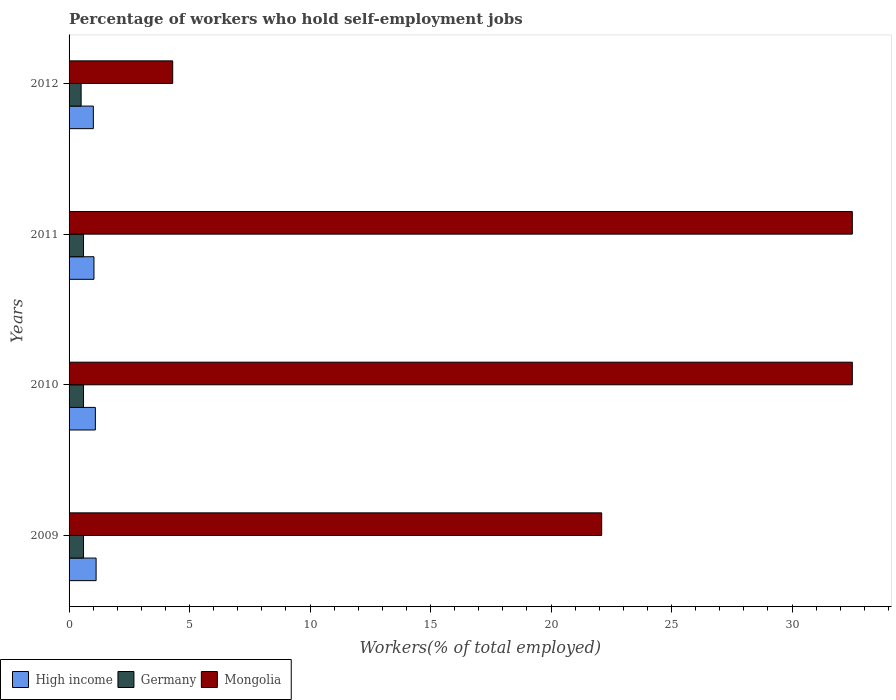How many different coloured bars are there?
Give a very brief answer. 3. How many groups of bars are there?
Make the answer very short. 4. Are the number of bars on each tick of the Y-axis equal?
Provide a succinct answer. Yes. How many bars are there on the 2nd tick from the top?
Offer a very short reply. 3. How many bars are there on the 1st tick from the bottom?
Offer a very short reply. 3. In how many cases, is the number of bars for a given year not equal to the number of legend labels?
Provide a short and direct response. 0. What is the percentage of self-employed workers in Germany in 2010?
Offer a very short reply. 0.6. Across all years, what is the maximum percentage of self-employed workers in Germany?
Offer a very short reply. 0.6. What is the total percentage of self-employed workers in High income in the graph?
Your answer should be very brief. 4.25. What is the difference between the percentage of self-employed workers in Germany in 2010 and the percentage of self-employed workers in High income in 2009?
Offer a terse response. -0.52. What is the average percentage of self-employed workers in High income per year?
Provide a short and direct response. 1.06. In the year 2009, what is the difference between the percentage of self-employed workers in High income and percentage of self-employed workers in Germany?
Keep it short and to the point. 0.52. In how many years, is the percentage of self-employed workers in Mongolia greater than 31 %?
Give a very brief answer. 2. What is the ratio of the percentage of self-employed workers in High income in 2011 to that in 2012?
Make the answer very short. 1.03. Is the difference between the percentage of self-employed workers in High income in 2011 and 2012 greater than the difference between the percentage of self-employed workers in Germany in 2011 and 2012?
Offer a terse response. No. What is the difference between the highest and the lowest percentage of self-employed workers in Mongolia?
Give a very brief answer. 28.2. In how many years, is the percentage of self-employed workers in Germany greater than the average percentage of self-employed workers in Germany taken over all years?
Provide a succinct answer. 3. What does the 1st bar from the bottom in 2011 represents?
Ensure brevity in your answer.  High income. Is it the case that in every year, the sum of the percentage of self-employed workers in High income and percentage of self-employed workers in Mongolia is greater than the percentage of self-employed workers in Germany?
Provide a succinct answer. Yes. How many years are there in the graph?
Keep it short and to the point. 4. Does the graph contain grids?
Your response must be concise. No. How many legend labels are there?
Your answer should be very brief. 3. How are the legend labels stacked?
Provide a short and direct response. Horizontal. What is the title of the graph?
Offer a terse response. Percentage of workers who hold self-employment jobs. What is the label or title of the X-axis?
Give a very brief answer. Workers(% of total employed). What is the label or title of the Y-axis?
Provide a succinct answer. Years. What is the Workers(% of total employed) of High income in 2009?
Your response must be concise. 1.12. What is the Workers(% of total employed) of Germany in 2009?
Make the answer very short. 0.6. What is the Workers(% of total employed) of Mongolia in 2009?
Provide a succinct answer. 22.1. What is the Workers(% of total employed) in High income in 2010?
Offer a very short reply. 1.09. What is the Workers(% of total employed) in Germany in 2010?
Ensure brevity in your answer.  0.6. What is the Workers(% of total employed) in Mongolia in 2010?
Provide a succinct answer. 32.5. What is the Workers(% of total employed) in High income in 2011?
Offer a terse response. 1.03. What is the Workers(% of total employed) of Germany in 2011?
Your answer should be compact. 0.6. What is the Workers(% of total employed) of Mongolia in 2011?
Your response must be concise. 32.5. What is the Workers(% of total employed) of High income in 2012?
Give a very brief answer. 1.01. What is the Workers(% of total employed) in Germany in 2012?
Ensure brevity in your answer.  0.5. What is the Workers(% of total employed) of Mongolia in 2012?
Your response must be concise. 4.3. Across all years, what is the maximum Workers(% of total employed) of High income?
Provide a short and direct response. 1.12. Across all years, what is the maximum Workers(% of total employed) of Germany?
Provide a short and direct response. 0.6. Across all years, what is the maximum Workers(% of total employed) in Mongolia?
Your response must be concise. 32.5. Across all years, what is the minimum Workers(% of total employed) in High income?
Offer a very short reply. 1.01. Across all years, what is the minimum Workers(% of total employed) of Mongolia?
Your response must be concise. 4.3. What is the total Workers(% of total employed) in High income in the graph?
Your response must be concise. 4.25. What is the total Workers(% of total employed) in Germany in the graph?
Provide a short and direct response. 2.3. What is the total Workers(% of total employed) in Mongolia in the graph?
Give a very brief answer. 91.4. What is the difference between the Workers(% of total employed) of High income in 2009 and that in 2010?
Make the answer very short. 0.03. What is the difference between the Workers(% of total employed) of Germany in 2009 and that in 2010?
Provide a short and direct response. 0. What is the difference between the Workers(% of total employed) of High income in 2009 and that in 2011?
Your answer should be very brief. 0.09. What is the difference between the Workers(% of total employed) in Germany in 2009 and that in 2011?
Offer a terse response. 0. What is the difference between the Workers(% of total employed) of Mongolia in 2009 and that in 2011?
Make the answer very short. -10.4. What is the difference between the Workers(% of total employed) of High income in 2009 and that in 2012?
Ensure brevity in your answer.  0.11. What is the difference between the Workers(% of total employed) in Germany in 2009 and that in 2012?
Provide a succinct answer. 0.1. What is the difference between the Workers(% of total employed) of Mongolia in 2009 and that in 2012?
Offer a very short reply. 17.8. What is the difference between the Workers(% of total employed) of High income in 2010 and that in 2011?
Give a very brief answer. 0.06. What is the difference between the Workers(% of total employed) in Germany in 2010 and that in 2011?
Keep it short and to the point. 0. What is the difference between the Workers(% of total employed) in Mongolia in 2010 and that in 2011?
Provide a succinct answer. 0. What is the difference between the Workers(% of total employed) of High income in 2010 and that in 2012?
Your answer should be very brief. 0.08. What is the difference between the Workers(% of total employed) of Germany in 2010 and that in 2012?
Offer a very short reply. 0.1. What is the difference between the Workers(% of total employed) in Mongolia in 2010 and that in 2012?
Your answer should be compact. 28.2. What is the difference between the Workers(% of total employed) in High income in 2011 and that in 2012?
Give a very brief answer. 0.03. What is the difference between the Workers(% of total employed) of Mongolia in 2011 and that in 2012?
Offer a very short reply. 28.2. What is the difference between the Workers(% of total employed) in High income in 2009 and the Workers(% of total employed) in Germany in 2010?
Offer a terse response. 0.52. What is the difference between the Workers(% of total employed) in High income in 2009 and the Workers(% of total employed) in Mongolia in 2010?
Ensure brevity in your answer.  -31.38. What is the difference between the Workers(% of total employed) in Germany in 2009 and the Workers(% of total employed) in Mongolia in 2010?
Ensure brevity in your answer.  -31.9. What is the difference between the Workers(% of total employed) of High income in 2009 and the Workers(% of total employed) of Germany in 2011?
Offer a very short reply. 0.52. What is the difference between the Workers(% of total employed) of High income in 2009 and the Workers(% of total employed) of Mongolia in 2011?
Provide a short and direct response. -31.38. What is the difference between the Workers(% of total employed) of Germany in 2009 and the Workers(% of total employed) of Mongolia in 2011?
Provide a succinct answer. -31.9. What is the difference between the Workers(% of total employed) in High income in 2009 and the Workers(% of total employed) in Germany in 2012?
Your response must be concise. 0.62. What is the difference between the Workers(% of total employed) in High income in 2009 and the Workers(% of total employed) in Mongolia in 2012?
Your response must be concise. -3.18. What is the difference between the Workers(% of total employed) in Germany in 2009 and the Workers(% of total employed) in Mongolia in 2012?
Ensure brevity in your answer.  -3.7. What is the difference between the Workers(% of total employed) of High income in 2010 and the Workers(% of total employed) of Germany in 2011?
Make the answer very short. 0.49. What is the difference between the Workers(% of total employed) in High income in 2010 and the Workers(% of total employed) in Mongolia in 2011?
Offer a terse response. -31.41. What is the difference between the Workers(% of total employed) in Germany in 2010 and the Workers(% of total employed) in Mongolia in 2011?
Provide a short and direct response. -31.9. What is the difference between the Workers(% of total employed) in High income in 2010 and the Workers(% of total employed) in Germany in 2012?
Your response must be concise. 0.59. What is the difference between the Workers(% of total employed) in High income in 2010 and the Workers(% of total employed) in Mongolia in 2012?
Make the answer very short. -3.21. What is the difference between the Workers(% of total employed) in Germany in 2010 and the Workers(% of total employed) in Mongolia in 2012?
Provide a short and direct response. -3.7. What is the difference between the Workers(% of total employed) of High income in 2011 and the Workers(% of total employed) of Germany in 2012?
Provide a short and direct response. 0.53. What is the difference between the Workers(% of total employed) in High income in 2011 and the Workers(% of total employed) in Mongolia in 2012?
Your answer should be compact. -3.27. What is the difference between the Workers(% of total employed) of Germany in 2011 and the Workers(% of total employed) of Mongolia in 2012?
Your answer should be very brief. -3.7. What is the average Workers(% of total employed) in High income per year?
Offer a terse response. 1.06. What is the average Workers(% of total employed) in Germany per year?
Your answer should be compact. 0.57. What is the average Workers(% of total employed) of Mongolia per year?
Provide a short and direct response. 22.85. In the year 2009, what is the difference between the Workers(% of total employed) in High income and Workers(% of total employed) in Germany?
Make the answer very short. 0.52. In the year 2009, what is the difference between the Workers(% of total employed) of High income and Workers(% of total employed) of Mongolia?
Your answer should be compact. -20.98. In the year 2009, what is the difference between the Workers(% of total employed) of Germany and Workers(% of total employed) of Mongolia?
Your answer should be very brief. -21.5. In the year 2010, what is the difference between the Workers(% of total employed) of High income and Workers(% of total employed) of Germany?
Give a very brief answer. 0.49. In the year 2010, what is the difference between the Workers(% of total employed) in High income and Workers(% of total employed) in Mongolia?
Keep it short and to the point. -31.41. In the year 2010, what is the difference between the Workers(% of total employed) of Germany and Workers(% of total employed) of Mongolia?
Provide a succinct answer. -31.9. In the year 2011, what is the difference between the Workers(% of total employed) in High income and Workers(% of total employed) in Germany?
Give a very brief answer. 0.43. In the year 2011, what is the difference between the Workers(% of total employed) in High income and Workers(% of total employed) in Mongolia?
Offer a terse response. -31.47. In the year 2011, what is the difference between the Workers(% of total employed) in Germany and Workers(% of total employed) in Mongolia?
Make the answer very short. -31.9. In the year 2012, what is the difference between the Workers(% of total employed) of High income and Workers(% of total employed) of Germany?
Give a very brief answer. 0.51. In the year 2012, what is the difference between the Workers(% of total employed) in High income and Workers(% of total employed) in Mongolia?
Your answer should be very brief. -3.29. In the year 2012, what is the difference between the Workers(% of total employed) of Germany and Workers(% of total employed) of Mongolia?
Offer a terse response. -3.8. What is the ratio of the Workers(% of total employed) of High income in 2009 to that in 2010?
Provide a succinct answer. 1.03. What is the ratio of the Workers(% of total employed) of Mongolia in 2009 to that in 2010?
Make the answer very short. 0.68. What is the ratio of the Workers(% of total employed) of High income in 2009 to that in 2011?
Ensure brevity in your answer.  1.09. What is the ratio of the Workers(% of total employed) of Mongolia in 2009 to that in 2011?
Keep it short and to the point. 0.68. What is the ratio of the Workers(% of total employed) of High income in 2009 to that in 2012?
Offer a terse response. 1.11. What is the ratio of the Workers(% of total employed) in Mongolia in 2009 to that in 2012?
Give a very brief answer. 5.14. What is the ratio of the Workers(% of total employed) in High income in 2010 to that in 2011?
Your answer should be very brief. 1.06. What is the ratio of the Workers(% of total employed) of Germany in 2010 to that in 2011?
Make the answer very short. 1. What is the ratio of the Workers(% of total employed) in High income in 2010 to that in 2012?
Your response must be concise. 1.08. What is the ratio of the Workers(% of total employed) in Germany in 2010 to that in 2012?
Your answer should be compact. 1.2. What is the ratio of the Workers(% of total employed) in Mongolia in 2010 to that in 2012?
Your answer should be very brief. 7.56. What is the ratio of the Workers(% of total employed) in High income in 2011 to that in 2012?
Make the answer very short. 1.03. What is the ratio of the Workers(% of total employed) in Germany in 2011 to that in 2012?
Provide a succinct answer. 1.2. What is the ratio of the Workers(% of total employed) in Mongolia in 2011 to that in 2012?
Your answer should be compact. 7.56. What is the difference between the highest and the second highest Workers(% of total employed) in High income?
Your answer should be very brief. 0.03. What is the difference between the highest and the second highest Workers(% of total employed) in Germany?
Give a very brief answer. 0. What is the difference between the highest and the second highest Workers(% of total employed) of Mongolia?
Your answer should be very brief. 0. What is the difference between the highest and the lowest Workers(% of total employed) in High income?
Give a very brief answer. 0.11. What is the difference between the highest and the lowest Workers(% of total employed) of Mongolia?
Your answer should be compact. 28.2. 